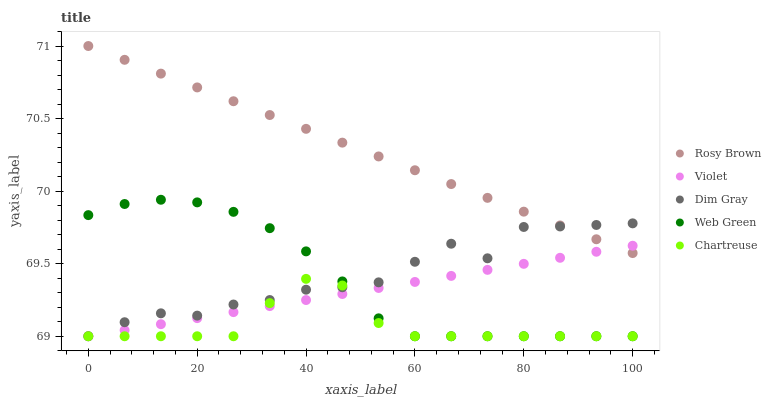Does Chartreuse have the minimum area under the curve?
Answer yes or no. Yes. Does Rosy Brown have the maximum area under the curve?
Answer yes or no. Yes. Does Rosy Brown have the minimum area under the curve?
Answer yes or no. No. Does Chartreuse have the maximum area under the curve?
Answer yes or no. No. Is Violet the smoothest?
Answer yes or no. Yes. Is Dim Gray the roughest?
Answer yes or no. Yes. Is Rosy Brown the smoothest?
Answer yes or no. No. Is Rosy Brown the roughest?
Answer yes or no. No. Does Dim Gray have the lowest value?
Answer yes or no. Yes. Does Rosy Brown have the lowest value?
Answer yes or no. No. Does Rosy Brown have the highest value?
Answer yes or no. Yes. Does Chartreuse have the highest value?
Answer yes or no. No. Is Chartreuse less than Rosy Brown?
Answer yes or no. Yes. Is Rosy Brown greater than Chartreuse?
Answer yes or no. Yes. Does Chartreuse intersect Violet?
Answer yes or no. Yes. Is Chartreuse less than Violet?
Answer yes or no. No. Is Chartreuse greater than Violet?
Answer yes or no. No. Does Chartreuse intersect Rosy Brown?
Answer yes or no. No. 